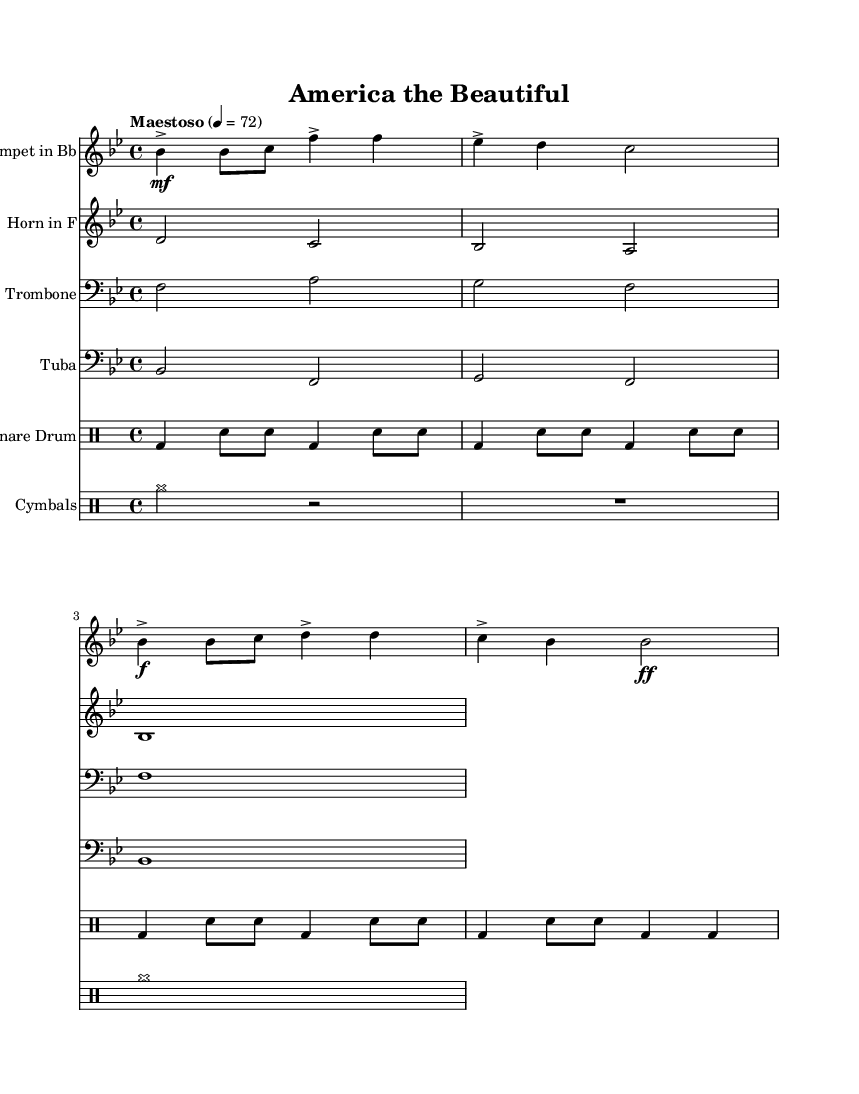What is the key signature of this music? The key signature is indicated at the beginning of the score and shows two flats (B flat and E flat), which corresponds to B flat major.
Answer: B flat major What is the time signature of the piece? The time signature is found at the beginning of the score, represented as a fraction. Here, it shows a "4" over a "4", indicating that there are four beats in each measure and the quarter note receives one beat.
Answer: 4/4 What is the tempo marking for this piece? The tempo marking is specified in the score, showing "Maestoso" with a metronome marking of 72. This indicates the speed at which the music should be played, which is generally slow and dignified.
Answer: Maestoso, 72 How many staves are used in this arrangement? By counting the number of distinct instrumental parts in the score, we identify five staves: one for trumpet, one for horn, one for trombone, one for tuba, and two for drums (snare and cymbals).
Answer: Five What instruments are featured in this arrangement? The instruments are listed at the beginning of each staff and include Trumpet in B flat, Horn in F, Trombone, Tuba, Snare Drum, and Cymbals.
Answer: Trumpet, Horn, Trombone, Tuba, Snare Drum, Cymbals What is the dynamic marking for the trumpet in the first measure? The dynamic marking appears near the start of the trumpet part, indicating that it begins with a "mf" (mezzo forte), meaning moderately loud.
Answer: mf 